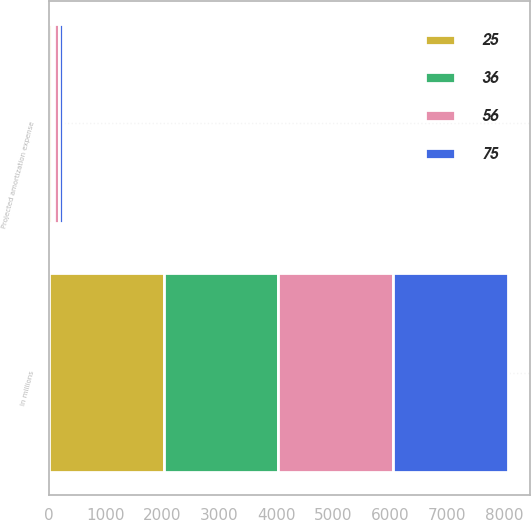Convert chart. <chart><loc_0><loc_0><loc_500><loc_500><stacked_bar_chart><ecel><fcel>In millions<fcel>Projected amortization expense<nl><fcel>56<fcel>2015<fcel>86<nl><fcel>75<fcel>2016<fcel>75<nl><fcel>25<fcel>2017<fcel>56<nl><fcel>36<fcel>2018<fcel>36<nl></chart> 